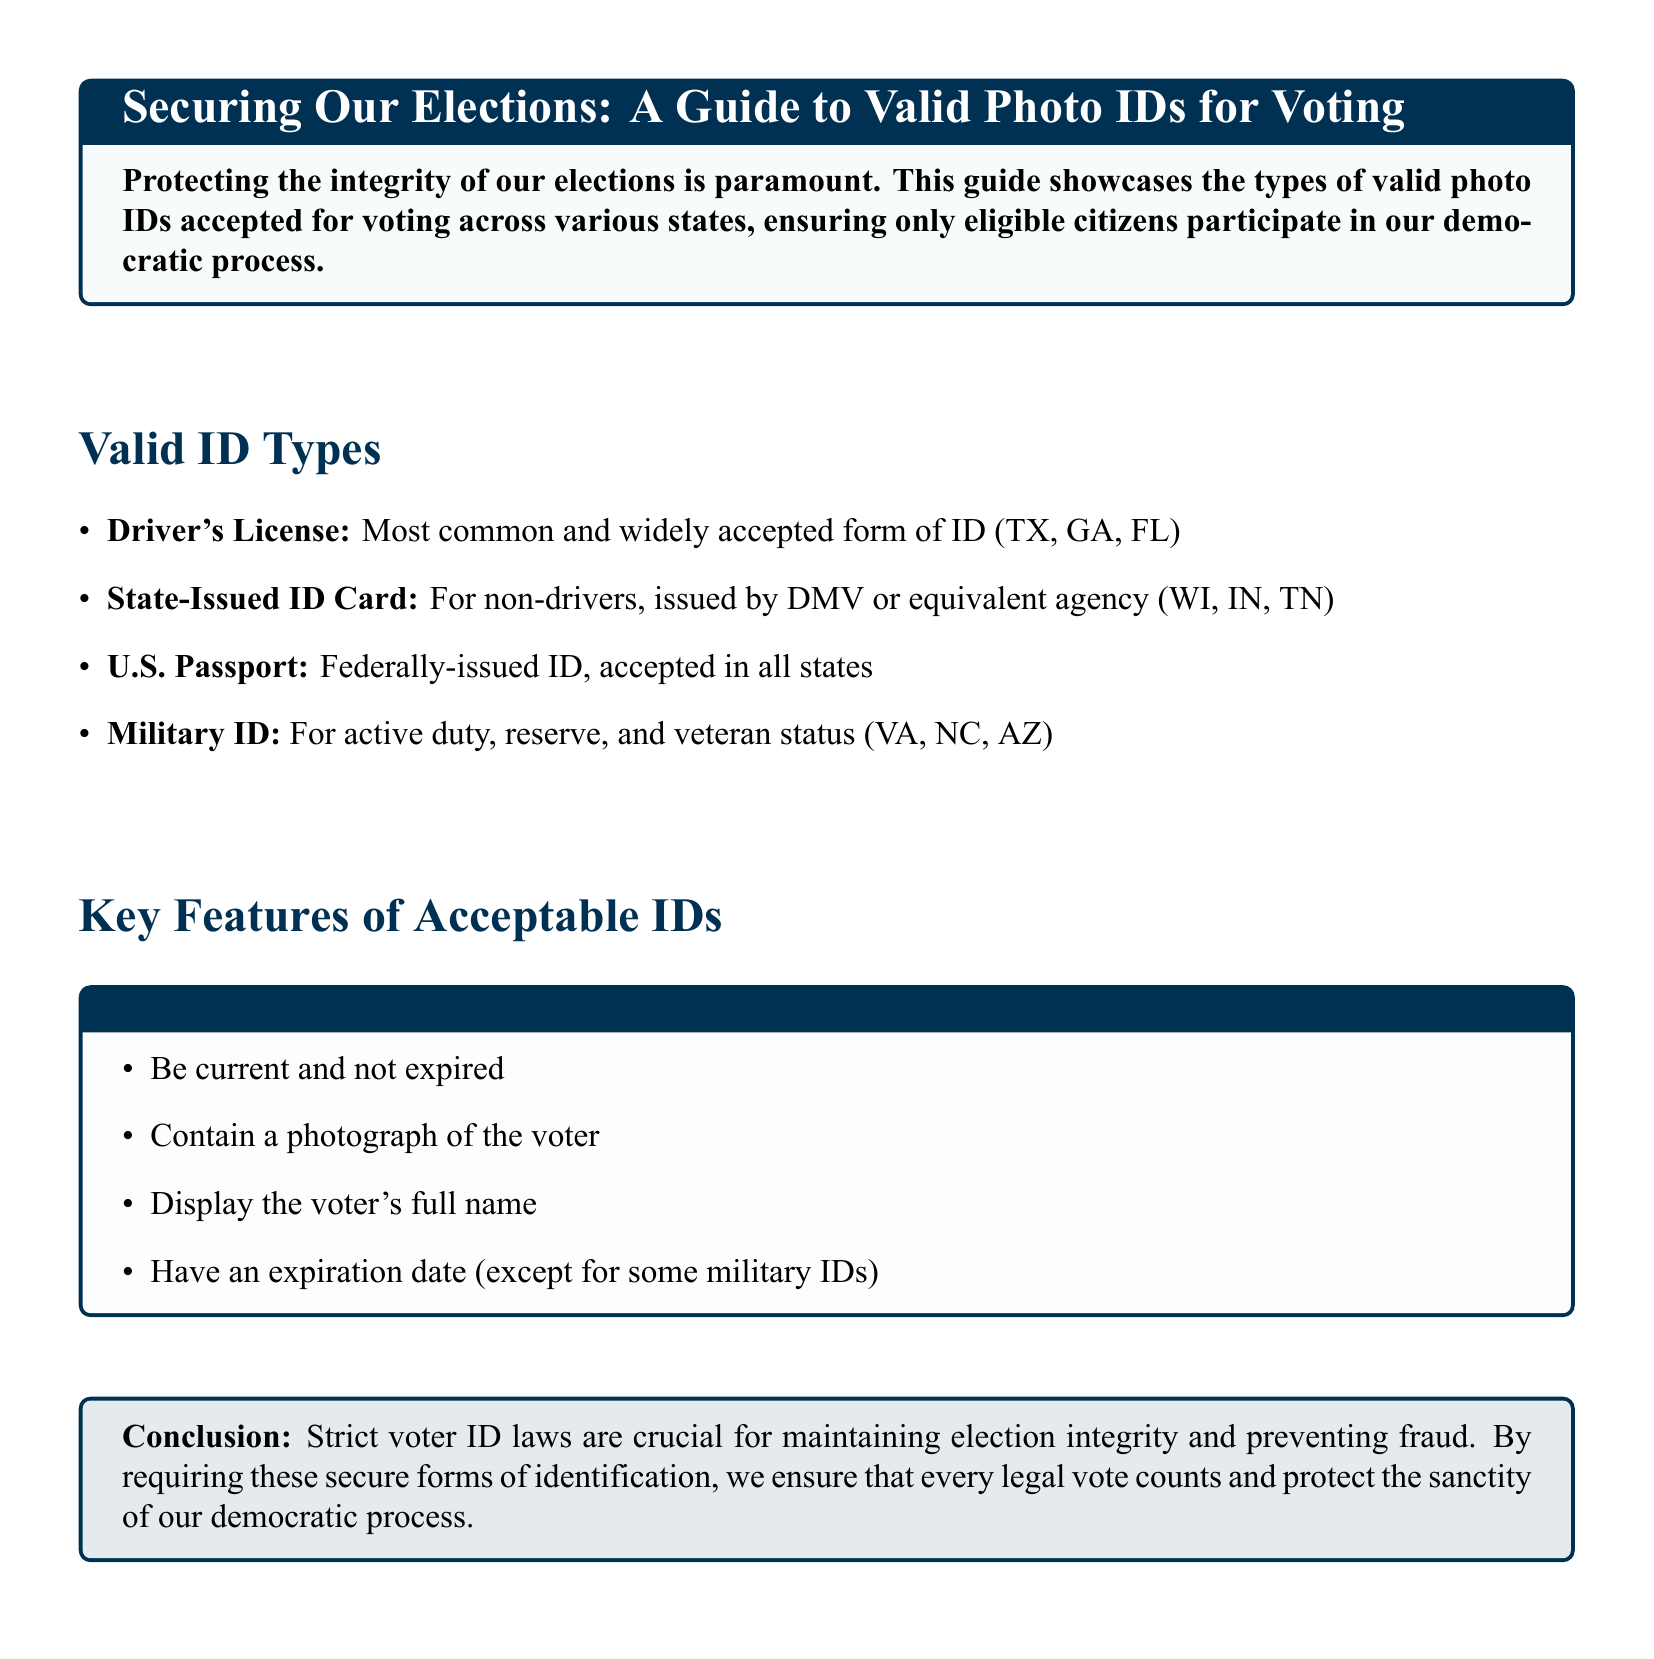What is the most common valid ID for voting? The most common valid ID for voting is mentioned as the Driver's License, which is widely accepted in states like Texas, Georgia, and Florida.
Answer: Driver's License Which states accept State-Issued ID Cards? The document lists Wisconsin, Indiana, and Tennessee as states that accept State-Issued ID Cards for voting.
Answer: Wisconsin, Indiana, Tennessee What type of ID is accepted in all states? The document states that the U.S. Passport is a type of ID that is accepted in all states for voting purposes.
Answer: U.S. Passport What must all valid IDs contain? The document specifies that all valid IDs must contain a photograph of the voter, among other requirements.
Answer: A photograph of the voter Why are strict voter ID laws important? The document concludes that strict voter ID laws are crucial for maintaining election integrity and preventing fraud, emphasizing the importance of legal votes.
Answer: Election integrity How many types of valid IDs are listed? The document outlines four types of valid IDs for voting purposes.
Answer: Four What is a requirement for military IDs mentioned? The document notes that military IDs must have an expiration date, except for some cases.
Answer: Have an expiration date What color is used in the document's design for titles? The color used for titles in the document is listed as conservative, which is defined in RGB terms.
Answer: Conservative 